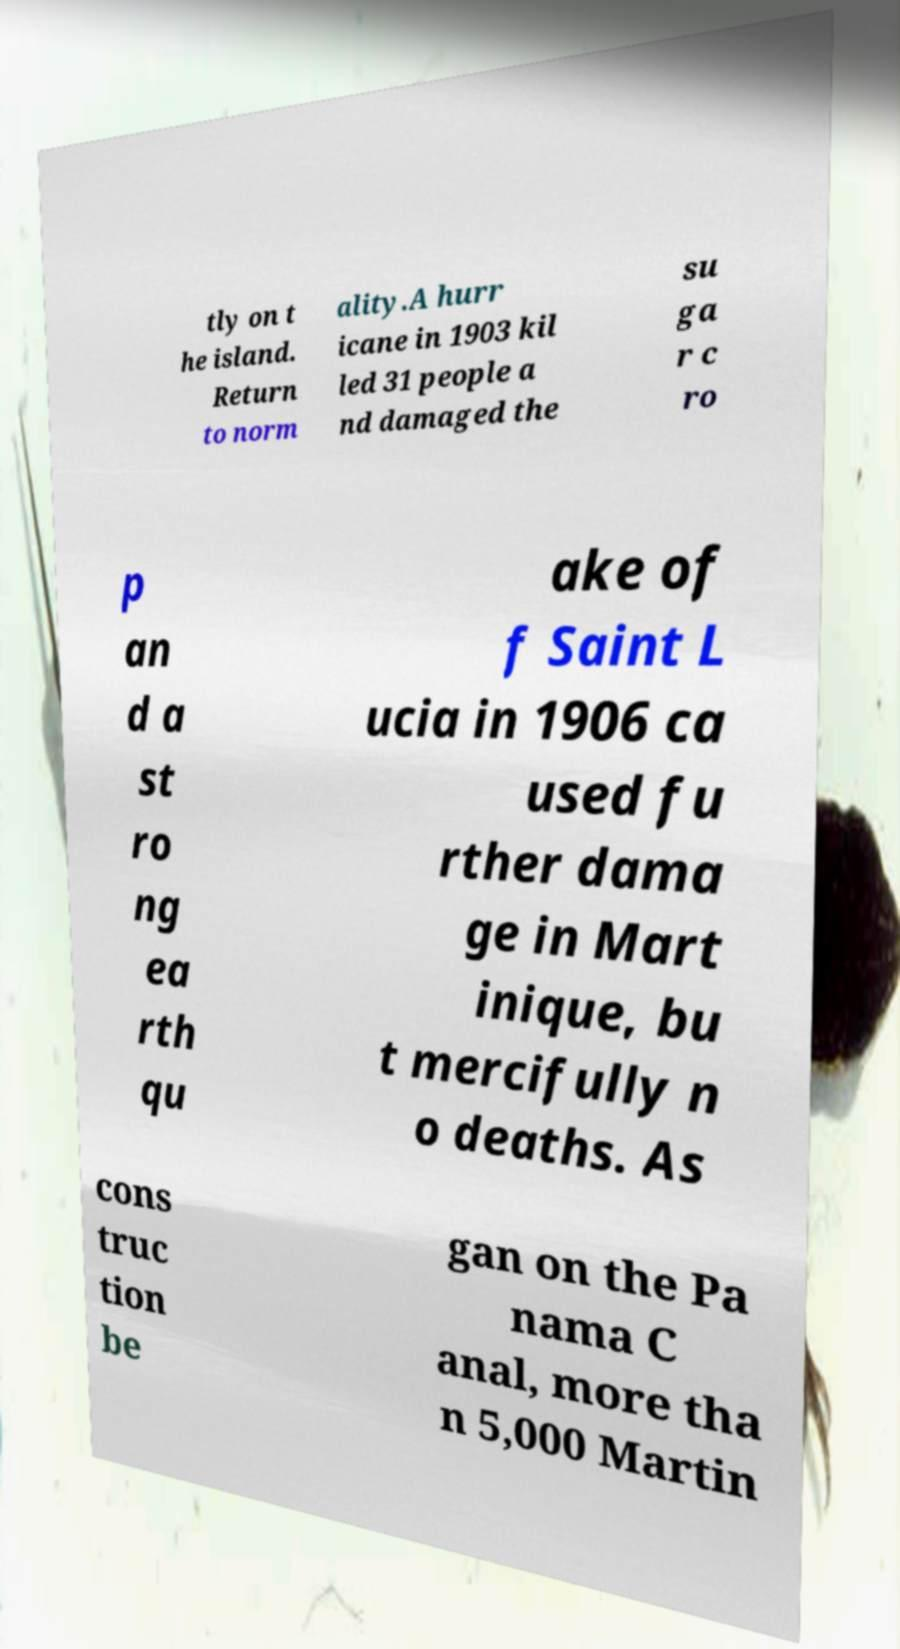I need the written content from this picture converted into text. Can you do that? tly on t he island. Return to norm ality.A hurr icane in 1903 kil led 31 people a nd damaged the su ga r c ro p an d a st ro ng ea rth qu ake of f Saint L ucia in 1906 ca used fu rther dama ge in Mart inique, bu t mercifully n o deaths. As cons truc tion be gan on the Pa nama C anal, more tha n 5,000 Martin 